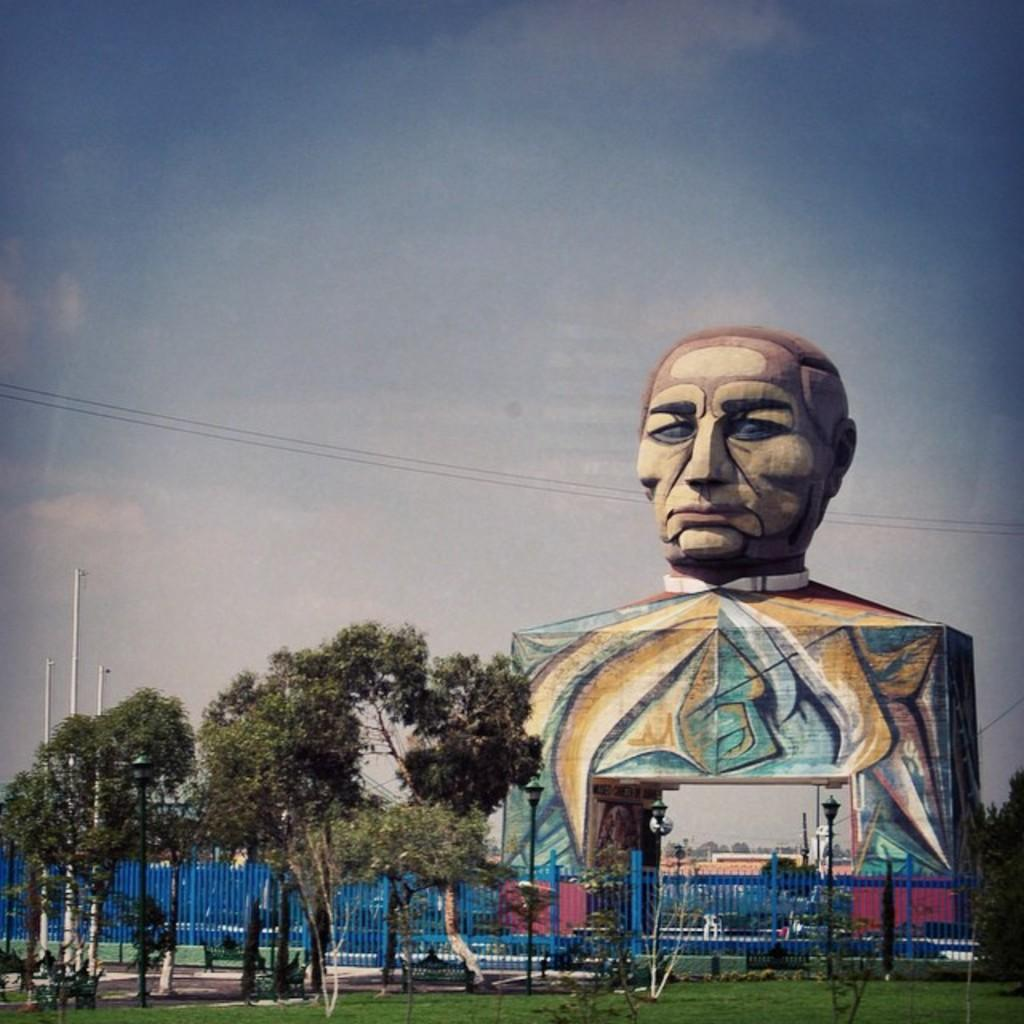What is the main subject in the image? There is a statue in the image. What can be observed on the statue? The statue has some painting on it. What type of lighting is present in the image? There are street lamps in the image. What type of barrier is present in the image? There is a fence in the image. What type of vegetation is present in the image? Grass and a group of trees are present in the image. What type of vertical structures are visible in the image? Poles are visible in the image. What type of electrical infrastructure is present in the image? Wires are present in the image. What part of the natural environment is visible in the image? The sky is visible in the image. What is the weather condition in the image? The sky appears cloudy in the image. Can you tell me how many fingers the statue has in the image? The statue is not a living being and does not have fingers; it is a sculpture. 